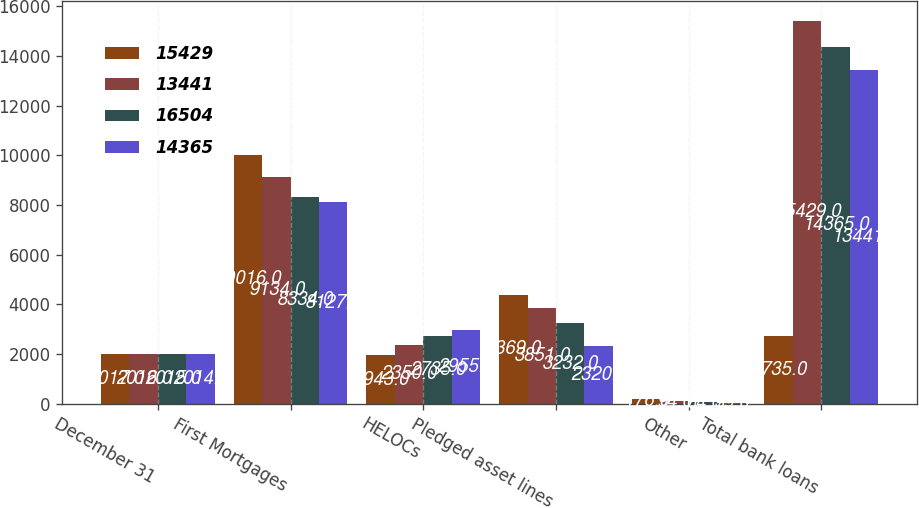Convert chart to OTSL. <chart><loc_0><loc_0><loc_500><loc_500><stacked_bar_chart><ecel><fcel>December 31<fcel>First Mortgages<fcel>HELOCs<fcel>Pledged asset lines<fcel>Other<fcel>Total bank loans<nl><fcel>15429<fcel>2017<fcel>10016<fcel>1943<fcel>4369<fcel>176<fcel>2735<nl><fcel>13441<fcel>2016<fcel>9134<fcel>2350<fcel>3851<fcel>94<fcel>15429<nl><fcel>16504<fcel>2015<fcel>8334<fcel>2735<fcel>3232<fcel>64<fcel>14365<nl><fcel>14365<fcel>2014<fcel>8127<fcel>2955<fcel>2320<fcel>39<fcel>13441<nl></chart> 